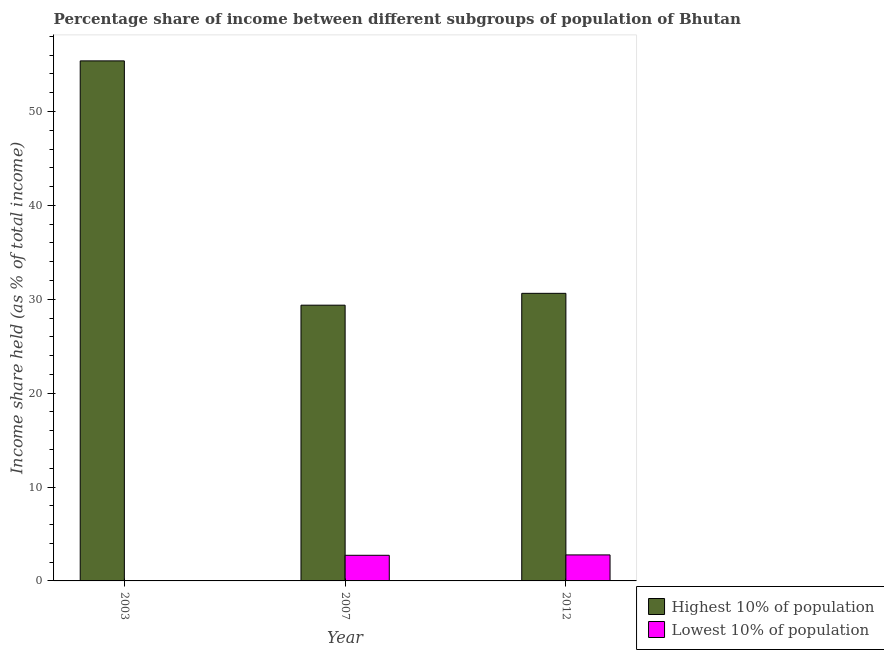How many different coloured bars are there?
Offer a very short reply. 2. How many groups of bars are there?
Your answer should be very brief. 3. Are the number of bars per tick equal to the number of legend labels?
Provide a succinct answer. Yes. How many bars are there on the 1st tick from the left?
Offer a terse response. 2. How many bars are there on the 2nd tick from the right?
Your answer should be compact. 2. What is the income share held by highest 10% of the population in 2007?
Make the answer very short. 29.37. Across all years, what is the maximum income share held by highest 10% of the population?
Keep it short and to the point. 55.39. What is the total income share held by highest 10% of the population in the graph?
Your answer should be compact. 115.39. What is the difference between the income share held by highest 10% of the population in 2003 and that in 2012?
Provide a short and direct response. 24.76. What is the difference between the income share held by highest 10% of the population in 2007 and the income share held by lowest 10% of the population in 2003?
Keep it short and to the point. -26.02. What is the average income share held by highest 10% of the population per year?
Offer a very short reply. 38.46. What is the ratio of the income share held by highest 10% of the population in 2003 to that in 2007?
Your response must be concise. 1.89. What is the difference between the highest and the second highest income share held by highest 10% of the population?
Your answer should be very brief. 24.76. What is the difference between the highest and the lowest income share held by lowest 10% of the population?
Provide a short and direct response. 2.74. In how many years, is the income share held by highest 10% of the population greater than the average income share held by highest 10% of the population taken over all years?
Keep it short and to the point. 1. Is the sum of the income share held by highest 10% of the population in 2003 and 2007 greater than the maximum income share held by lowest 10% of the population across all years?
Your answer should be very brief. Yes. What does the 1st bar from the left in 2007 represents?
Offer a terse response. Highest 10% of population. What does the 1st bar from the right in 2012 represents?
Make the answer very short. Lowest 10% of population. Are all the bars in the graph horizontal?
Your response must be concise. No. How many years are there in the graph?
Provide a short and direct response. 3. Are the values on the major ticks of Y-axis written in scientific E-notation?
Keep it short and to the point. No. Does the graph contain any zero values?
Ensure brevity in your answer.  No. How are the legend labels stacked?
Your response must be concise. Vertical. What is the title of the graph?
Your answer should be very brief. Percentage share of income between different subgroups of population of Bhutan. What is the label or title of the Y-axis?
Your response must be concise. Income share held (as % of total income). What is the Income share held (as % of total income) in Highest 10% of population in 2003?
Provide a short and direct response. 55.39. What is the Income share held (as % of total income) of Lowest 10% of population in 2003?
Provide a short and direct response. 0.03. What is the Income share held (as % of total income) of Highest 10% of population in 2007?
Keep it short and to the point. 29.37. What is the Income share held (as % of total income) of Lowest 10% of population in 2007?
Your answer should be compact. 2.73. What is the Income share held (as % of total income) in Highest 10% of population in 2012?
Provide a succinct answer. 30.63. What is the Income share held (as % of total income) in Lowest 10% of population in 2012?
Your response must be concise. 2.77. Across all years, what is the maximum Income share held (as % of total income) in Highest 10% of population?
Offer a very short reply. 55.39. Across all years, what is the maximum Income share held (as % of total income) of Lowest 10% of population?
Provide a short and direct response. 2.77. Across all years, what is the minimum Income share held (as % of total income) of Highest 10% of population?
Your response must be concise. 29.37. What is the total Income share held (as % of total income) of Highest 10% of population in the graph?
Ensure brevity in your answer.  115.39. What is the total Income share held (as % of total income) of Lowest 10% of population in the graph?
Offer a very short reply. 5.53. What is the difference between the Income share held (as % of total income) of Highest 10% of population in 2003 and that in 2007?
Offer a terse response. 26.02. What is the difference between the Income share held (as % of total income) of Highest 10% of population in 2003 and that in 2012?
Provide a succinct answer. 24.76. What is the difference between the Income share held (as % of total income) of Lowest 10% of population in 2003 and that in 2012?
Provide a short and direct response. -2.74. What is the difference between the Income share held (as % of total income) of Highest 10% of population in 2007 and that in 2012?
Provide a succinct answer. -1.26. What is the difference between the Income share held (as % of total income) of Lowest 10% of population in 2007 and that in 2012?
Ensure brevity in your answer.  -0.04. What is the difference between the Income share held (as % of total income) of Highest 10% of population in 2003 and the Income share held (as % of total income) of Lowest 10% of population in 2007?
Provide a succinct answer. 52.66. What is the difference between the Income share held (as % of total income) in Highest 10% of population in 2003 and the Income share held (as % of total income) in Lowest 10% of population in 2012?
Your response must be concise. 52.62. What is the difference between the Income share held (as % of total income) of Highest 10% of population in 2007 and the Income share held (as % of total income) of Lowest 10% of population in 2012?
Keep it short and to the point. 26.6. What is the average Income share held (as % of total income) in Highest 10% of population per year?
Provide a succinct answer. 38.46. What is the average Income share held (as % of total income) of Lowest 10% of population per year?
Your answer should be very brief. 1.84. In the year 2003, what is the difference between the Income share held (as % of total income) in Highest 10% of population and Income share held (as % of total income) in Lowest 10% of population?
Your answer should be very brief. 55.36. In the year 2007, what is the difference between the Income share held (as % of total income) of Highest 10% of population and Income share held (as % of total income) of Lowest 10% of population?
Give a very brief answer. 26.64. In the year 2012, what is the difference between the Income share held (as % of total income) in Highest 10% of population and Income share held (as % of total income) in Lowest 10% of population?
Ensure brevity in your answer.  27.86. What is the ratio of the Income share held (as % of total income) in Highest 10% of population in 2003 to that in 2007?
Provide a succinct answer. 1.89. What is the ratio of the Income share held (as % of total income) in Lowest 10% of population in 2003 to that in 2007?
Offer a terse response. 0.01. What is the ratio of the Income share held (as % of total income) in Highest 10% of population in 2003 to that in 2012?
Provide a short and direct response. 1.81. What is the ratio of the Income share held (as % of total income) of Lowest 10% of population in 2003 to that in 2012?
Offer a terse response. 0.01. What is the ratio of the Income share held (as % of total income) in Highest 10% of population in 2007 to that in 2012?
Provide a succinct answer. 0.96. What is the ratio of the Income share held (as % of total income) in Lowest 10% of population in 2007 to that in 2012?
Provide a succinct answer. 0.99. What is the difference between the highest and the second highest Income share held (as % of total income) in Highest 10% of population?
Your response must be concise. 24.76. What is the difference between the highest and the second highest Income share held (as % of total income) in Lowest 10% of population?
Your response must be concise. 0.04. What is the difference between the highest and the lowest Income share held (as % of total income) of Highest 10% of population?
Keep it short and to the point. 26.02. What is the difference between the highest and the lowest Income share held (as % of total income) in Lowest 10% of population?
Provide a short and direct response. 2.74. 